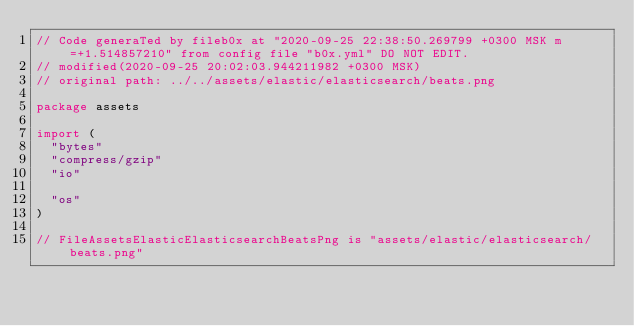Convert code to text. <code><loc_0><loc_0><loc_500><loc_500><_Go_>// Code generaTed by fileb0x at "2020-09-25 22:38:50.269799 +0300 MSK m=+1.514857210" from config file "b0x.yml" DO NOT EDIT.
// modified(2020-09-25 20:02:03.944211982 +0300 MSK)
// original path: ../../assets/elastic/elasticsearch/beats.png

package assets

import (
	"bytes"
	"compress/gzip"
	"io"

	"os"
)

// FileAssetsElasticElasticsearchBeatsPng is "assets/elastic/elasticsearch/beats.png"</code> 